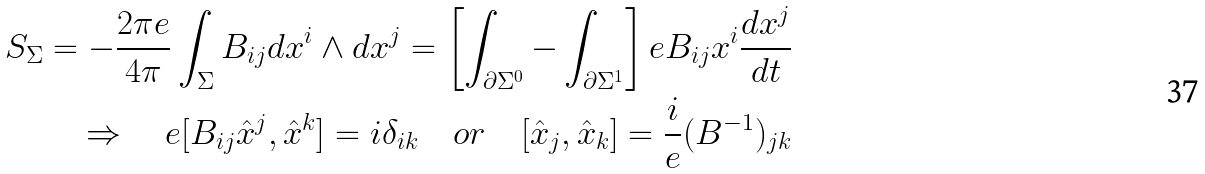<formula> <loc_0><loc_0><loc_500><loc_500>S _ { \Sigma } = - \frac { 2 \pi e } { 4 \pi } \int _ { \Sigma } B _ { i j } d x ^ { i } \wedge d x ^ { j } = \left [ \int _ { \partial \Sigma ^ { 0 } } - \int _ { \partial \Sigma ^ { 1 } } \right ] e B _ { i j } x ^ { i } \frac { d x ^ { j } } { d t } \\ \Rightarrow \quad e [ B _ { i j } \hat { x } ^ { j } , \hat { x } ^ { k } ] = i \delta _ { i k } \quad o r \quad [ \hat { x } _ { j } , \hat { x } _ { k } ] = \frac { i } { e } ( B ^ { - 1 } ) _ { j k }</formula> 